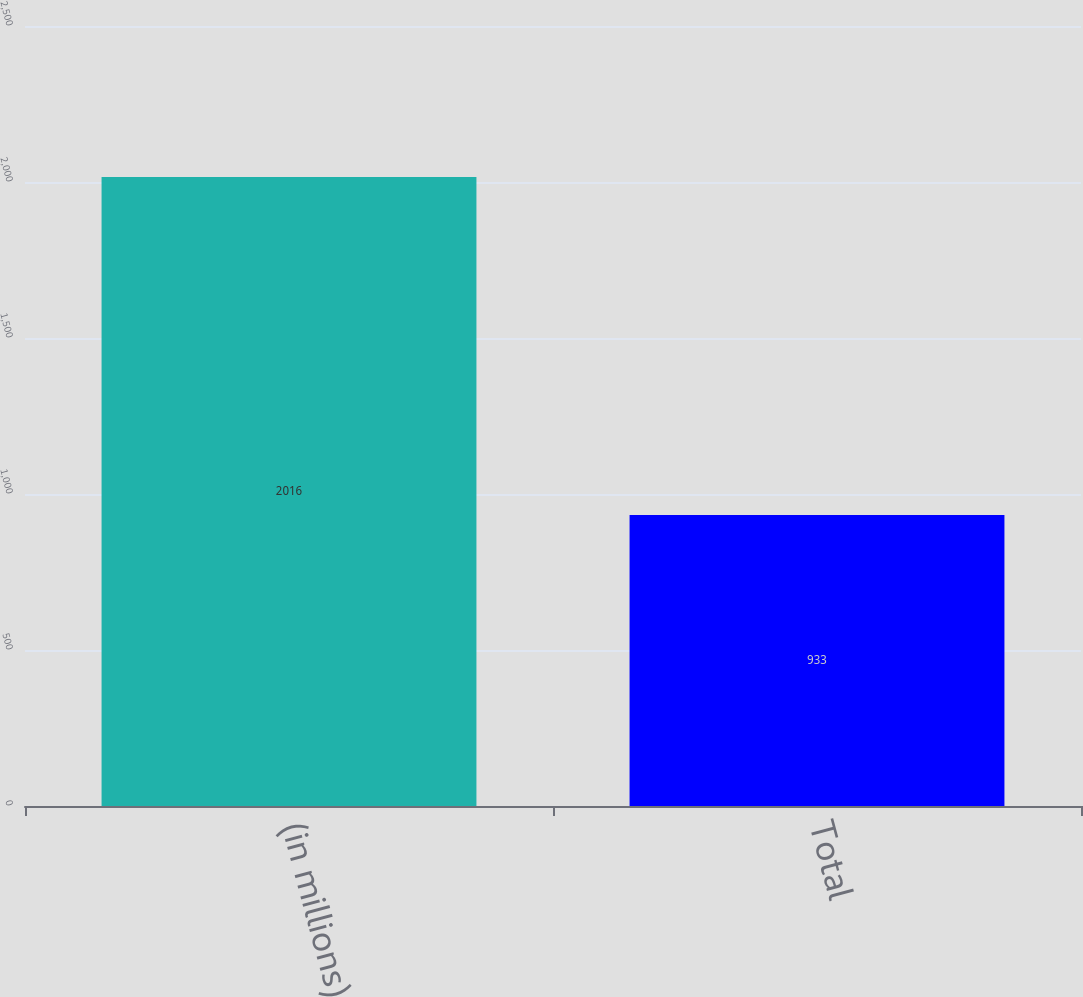Convert chart to OTSL. <chart><loc_0><loc_0><loc_500><loc_500><bar_chart><fcel>(in millions)<fcel>Total<nl><fcel>2016<fcel>933<nl></chart> 